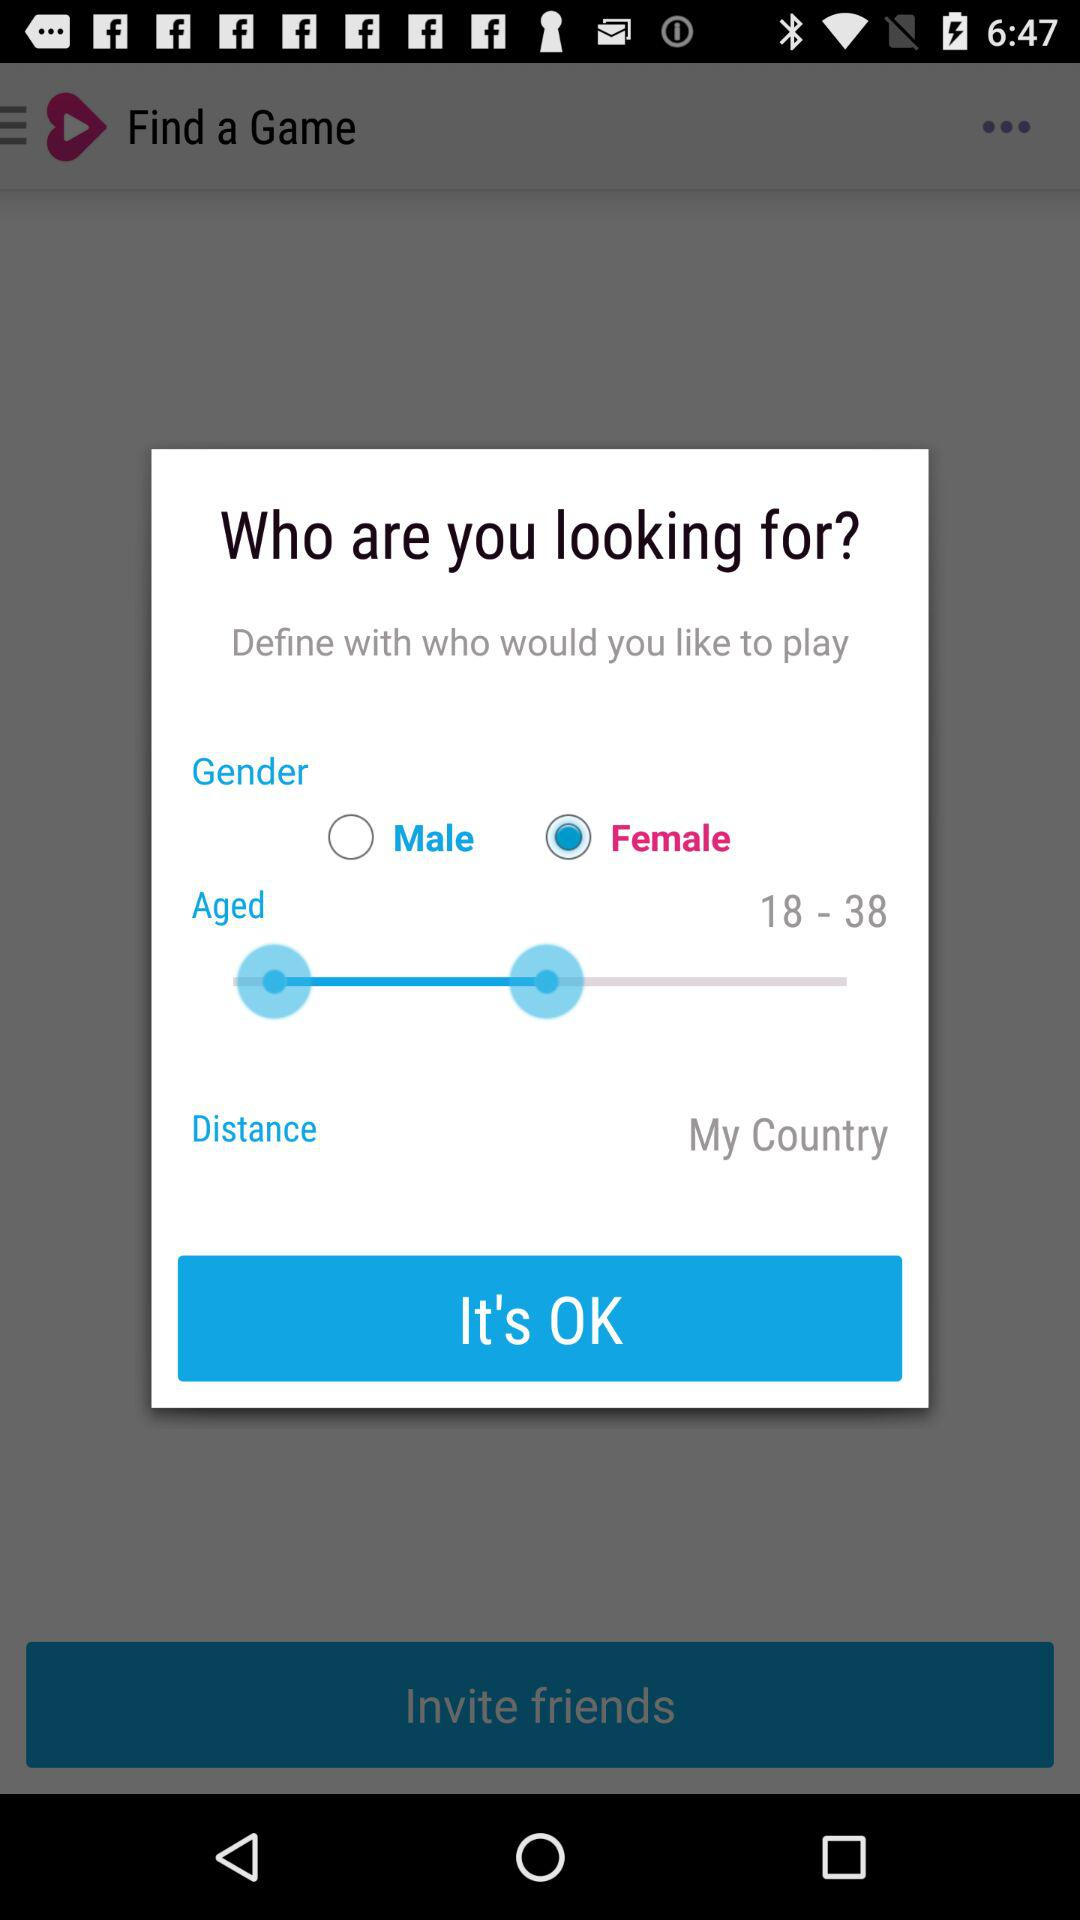How many gender options are available?
Answer the question using a single word or phrase. 2 